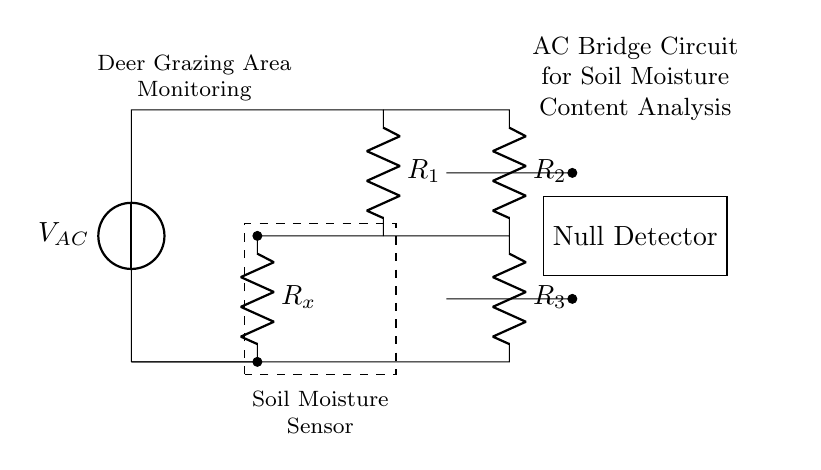What is the purpose of this circuit? The circuit is designed for soil moisture content analysis in deer grazing areas, as indicated in the label.
Answer: Soil moisture content analysis What components are present in the AC bridge circuit? The circuit includes resistors and a voltage source. More specifically, it has R1, R2, R3, and Rx.
Answer: R1, R2, R3, Rx What type of detector is used in this circuit? A null detector is used to measure the balance in the bridge circuit.
Answer: Null detector How many resistors are in series with the soil moisture sensor? Two resistors, R2 and Rx, are effectively in series with the sensor in the bridged configuration.
Answer: Two What is the role of the soil moisture sensor in the circuit? The sensor measures the resistance, which varies with soil moisture content, allowing for analysis in the grazing area.
Answer: Measures soil moisture What configuration is this circuit utilizing? This circuit is utilizing an AC bridge configuration, which is typically used for precise measurements like resistances and capacitance.
Answer: AC bridge At what point is the voltage measured in this circuit? The voltage is measured at the output of the null detector, which helps establish the balance of the bridge circuit.
Answer: At the null detector 